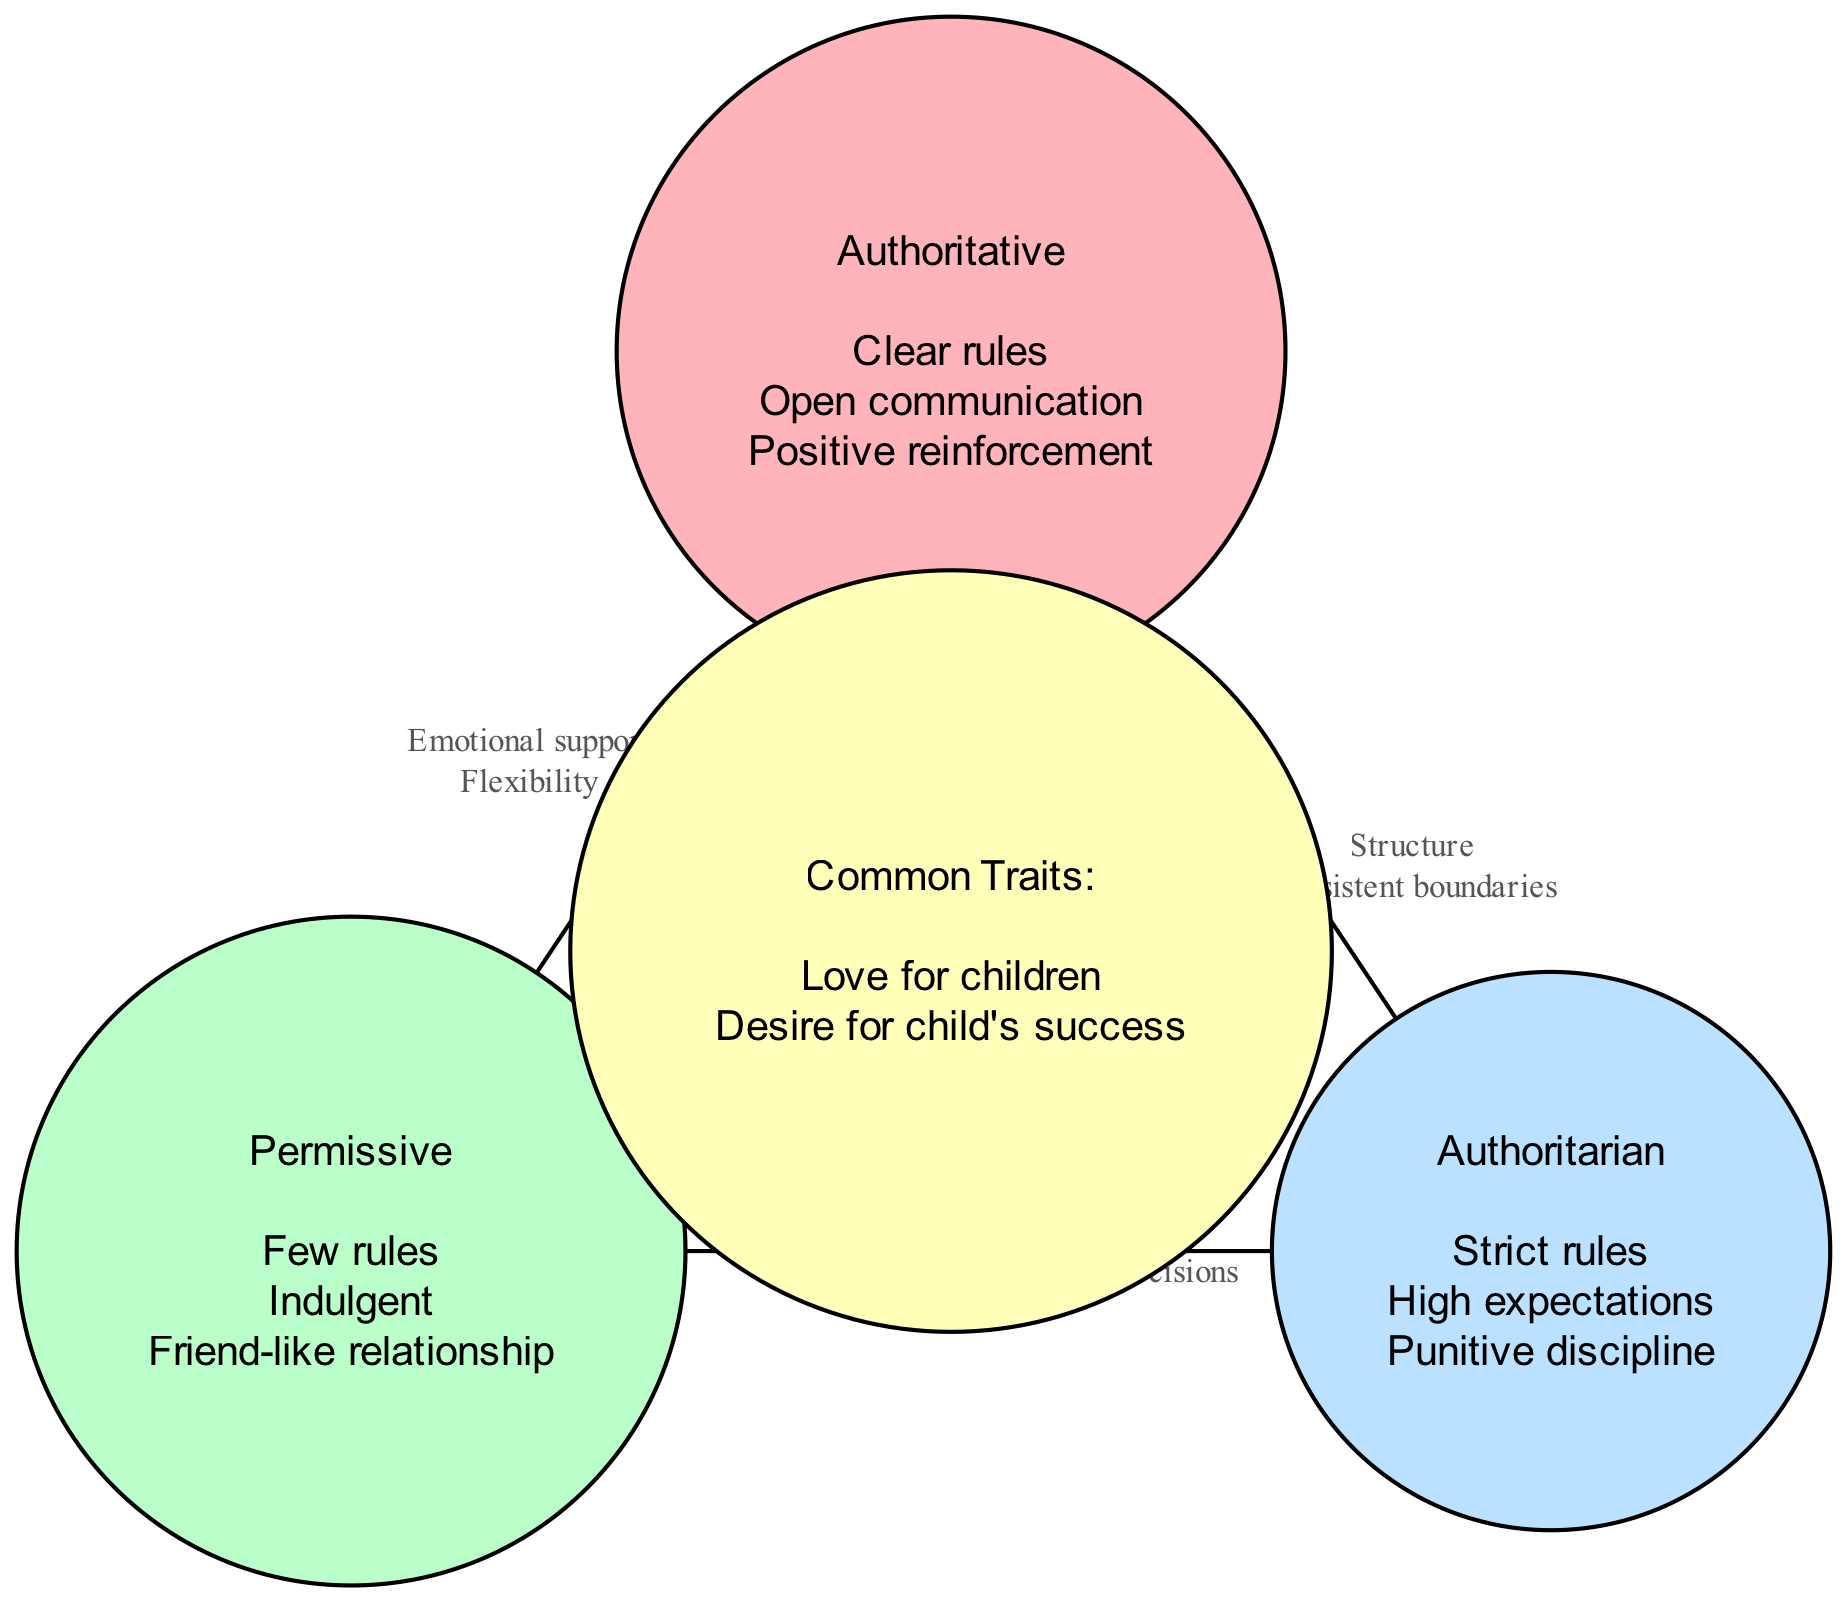What are the characteristics of the Authoritative parenting style? The Authoritative parenting style is represented by a circle that lists "Clear rules," "Open communication," and "Positive reinforcement" as its characteristics.
Answer: Clear rules, Open communication, Positive reinforcement What characteristics are shared between Authoritative and Permissive styles? The overlapping area between the Authoritative and Permissive circles indicates the shared characteristics of "Emotional support" and "Flexibility."
Answer: Emotional support, Flexibility How many characteristics does the Authoritarian parenting style have? The Authoritarian parenting style contains three characteristics: "Strict rules," "High expectations," and "Punitive discipline." Therefore, it has a total of three characteristics.
Answer: 3 What is a characteristic common to all parenting styles listed in the center? The center node of the diagram displays common traits that are "Love for children" and "Desire for child's success," indicating that these traits are shared among all parenting styles.
Answer: Love for children, Desire for child's success Which parenting styles share the characteristic of "Parent-centered decisions"? The diagram has an overlapping area between Permissive and Authoritarian styles that lists "Parent-centered decisions," indicating this characteristic is shared between these two styles.
Answer: Permissive and Authoritarian What is the main difference between Authoritative and Authoritarian parenting styles based on the diagram? The main difference can be identified as Authoritative emphasizes "Open communication" and "Positive reinforcement," while Authoritarian focuses on "Strict rules" and "Punitive discipline."
Answer: Open communication vs. Strict rules How many overlapping characteristics are there in total? There are three sets of overlapping characteristics detailed between the different parenting styles: Authoritative & Permissive, Authoritative & Authoritarian, and Permissive & Authoritarian, which account for a total of three overlaps.
Answer: 3 What unique feature does the Permissive parenting style exhibit compared to the others? The Permissive parenting style is characterized by "Few rules" and being "Indulgent," which distinguishes it from the more structured approaches of Authoritative and Authoritarian styles.
Answer: Few rules, Indulgent Which parenting styles emphasize structure as a characteristic? "Structure" is specifically mentioned as a characteristic shared between Authoritative and Authoritarian parenting styles, highlighting their focus on providing a structured environment for children.
Answer: Authoritative and Authoritarian 